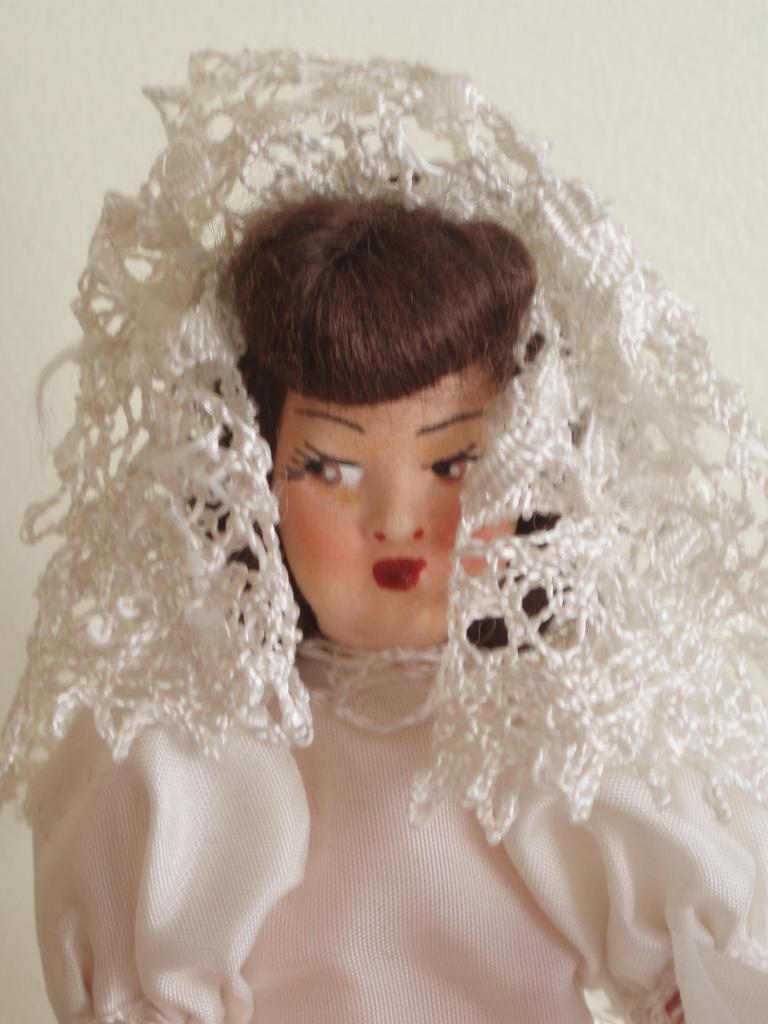What is the main subject in the center of the image? There is a doll in the center of the image. What can be seen in the background of the image? There is a wall visible in the background of the image. Who is the creator of the patch on the wall in the image? There is no patch visible on the wall in the image, so it is not possible to determine who the creator might be. 